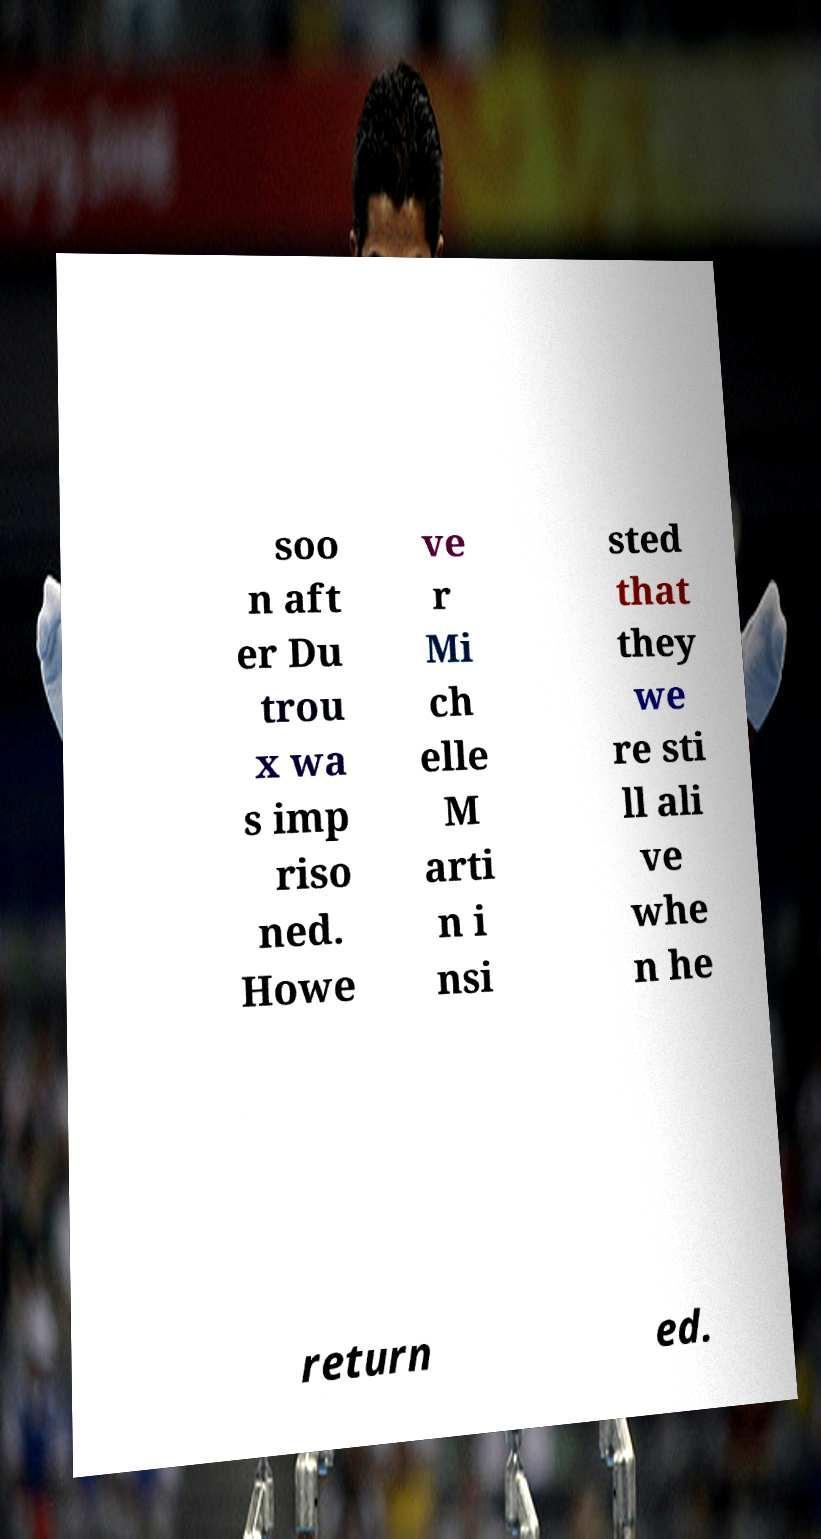I need the written content from this picture converted into text. Can you do that? soo n aft er Du trou x wa s imp riso ned. Howe ve r Mi ch elle M arti n i nsi sted that they we re sti ll ali ve whe n he return ed. 